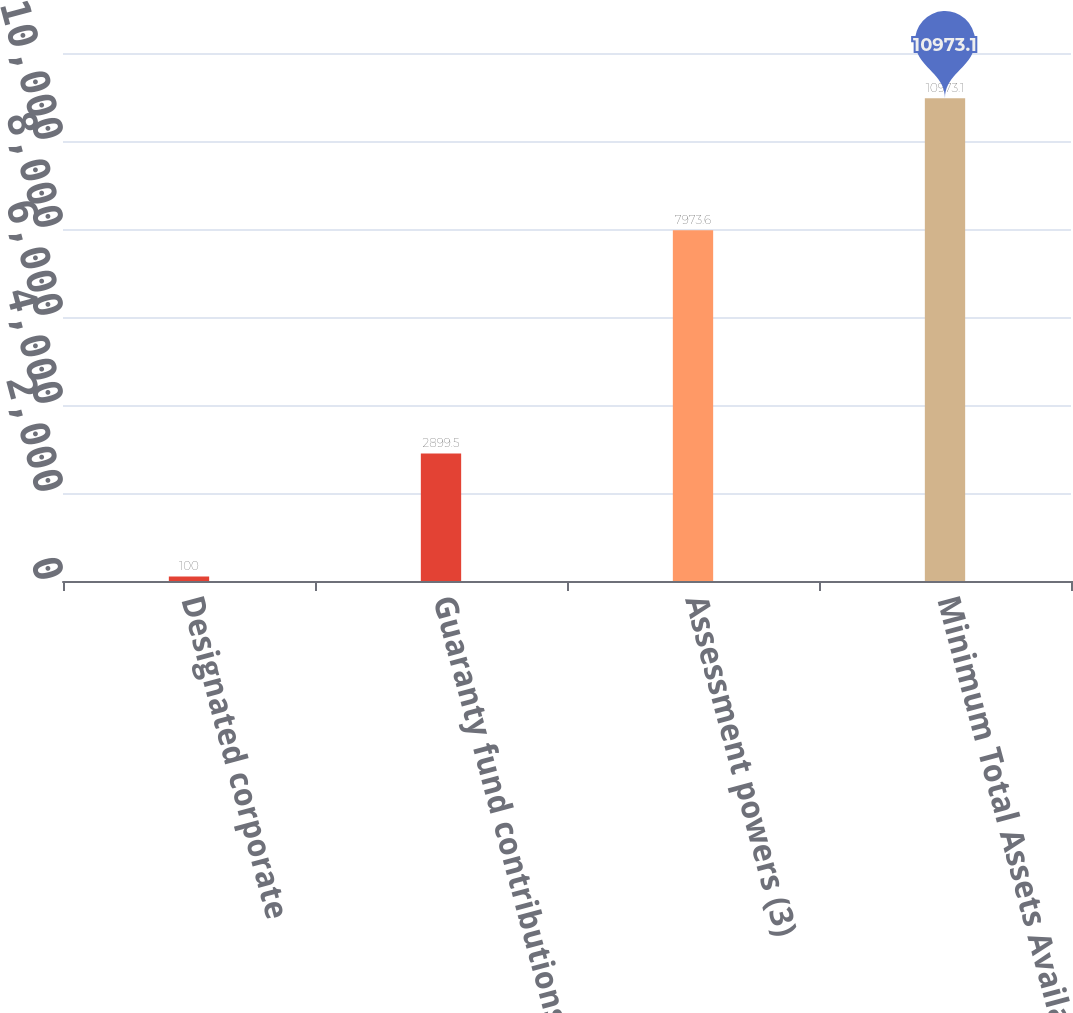Convert chart to OTSL. <chart><loc_0><loc_0><loc_500><loc_500><bar_chart><fcel>Designated corporate<fcel>Guaranty fund contributions<fcel>Assessment powers (3)<fcel>Minimum Total Assets Available<nl><fcel>100<fcel>2899.5<fcel>7973.6<fcel>10973.1<nl></chart> 